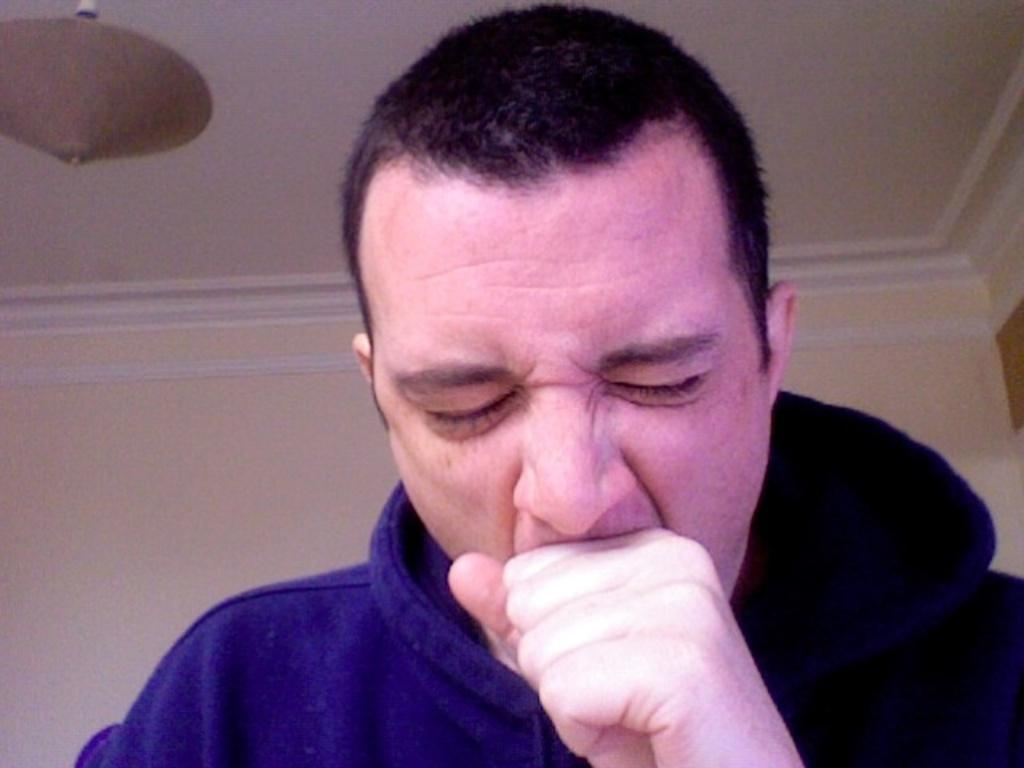Who or what is the main subject in the image? There is a person in the image. What is behind the person in the image? There is a wall behind the person. Can you describe anything hanging from the ceiling in the image? There is an object hanging from the ceiling at the top of the image. Who is the creator of the roof in the image? There is no roof present in the image, so it is not possible to determine the creator of a roof. 